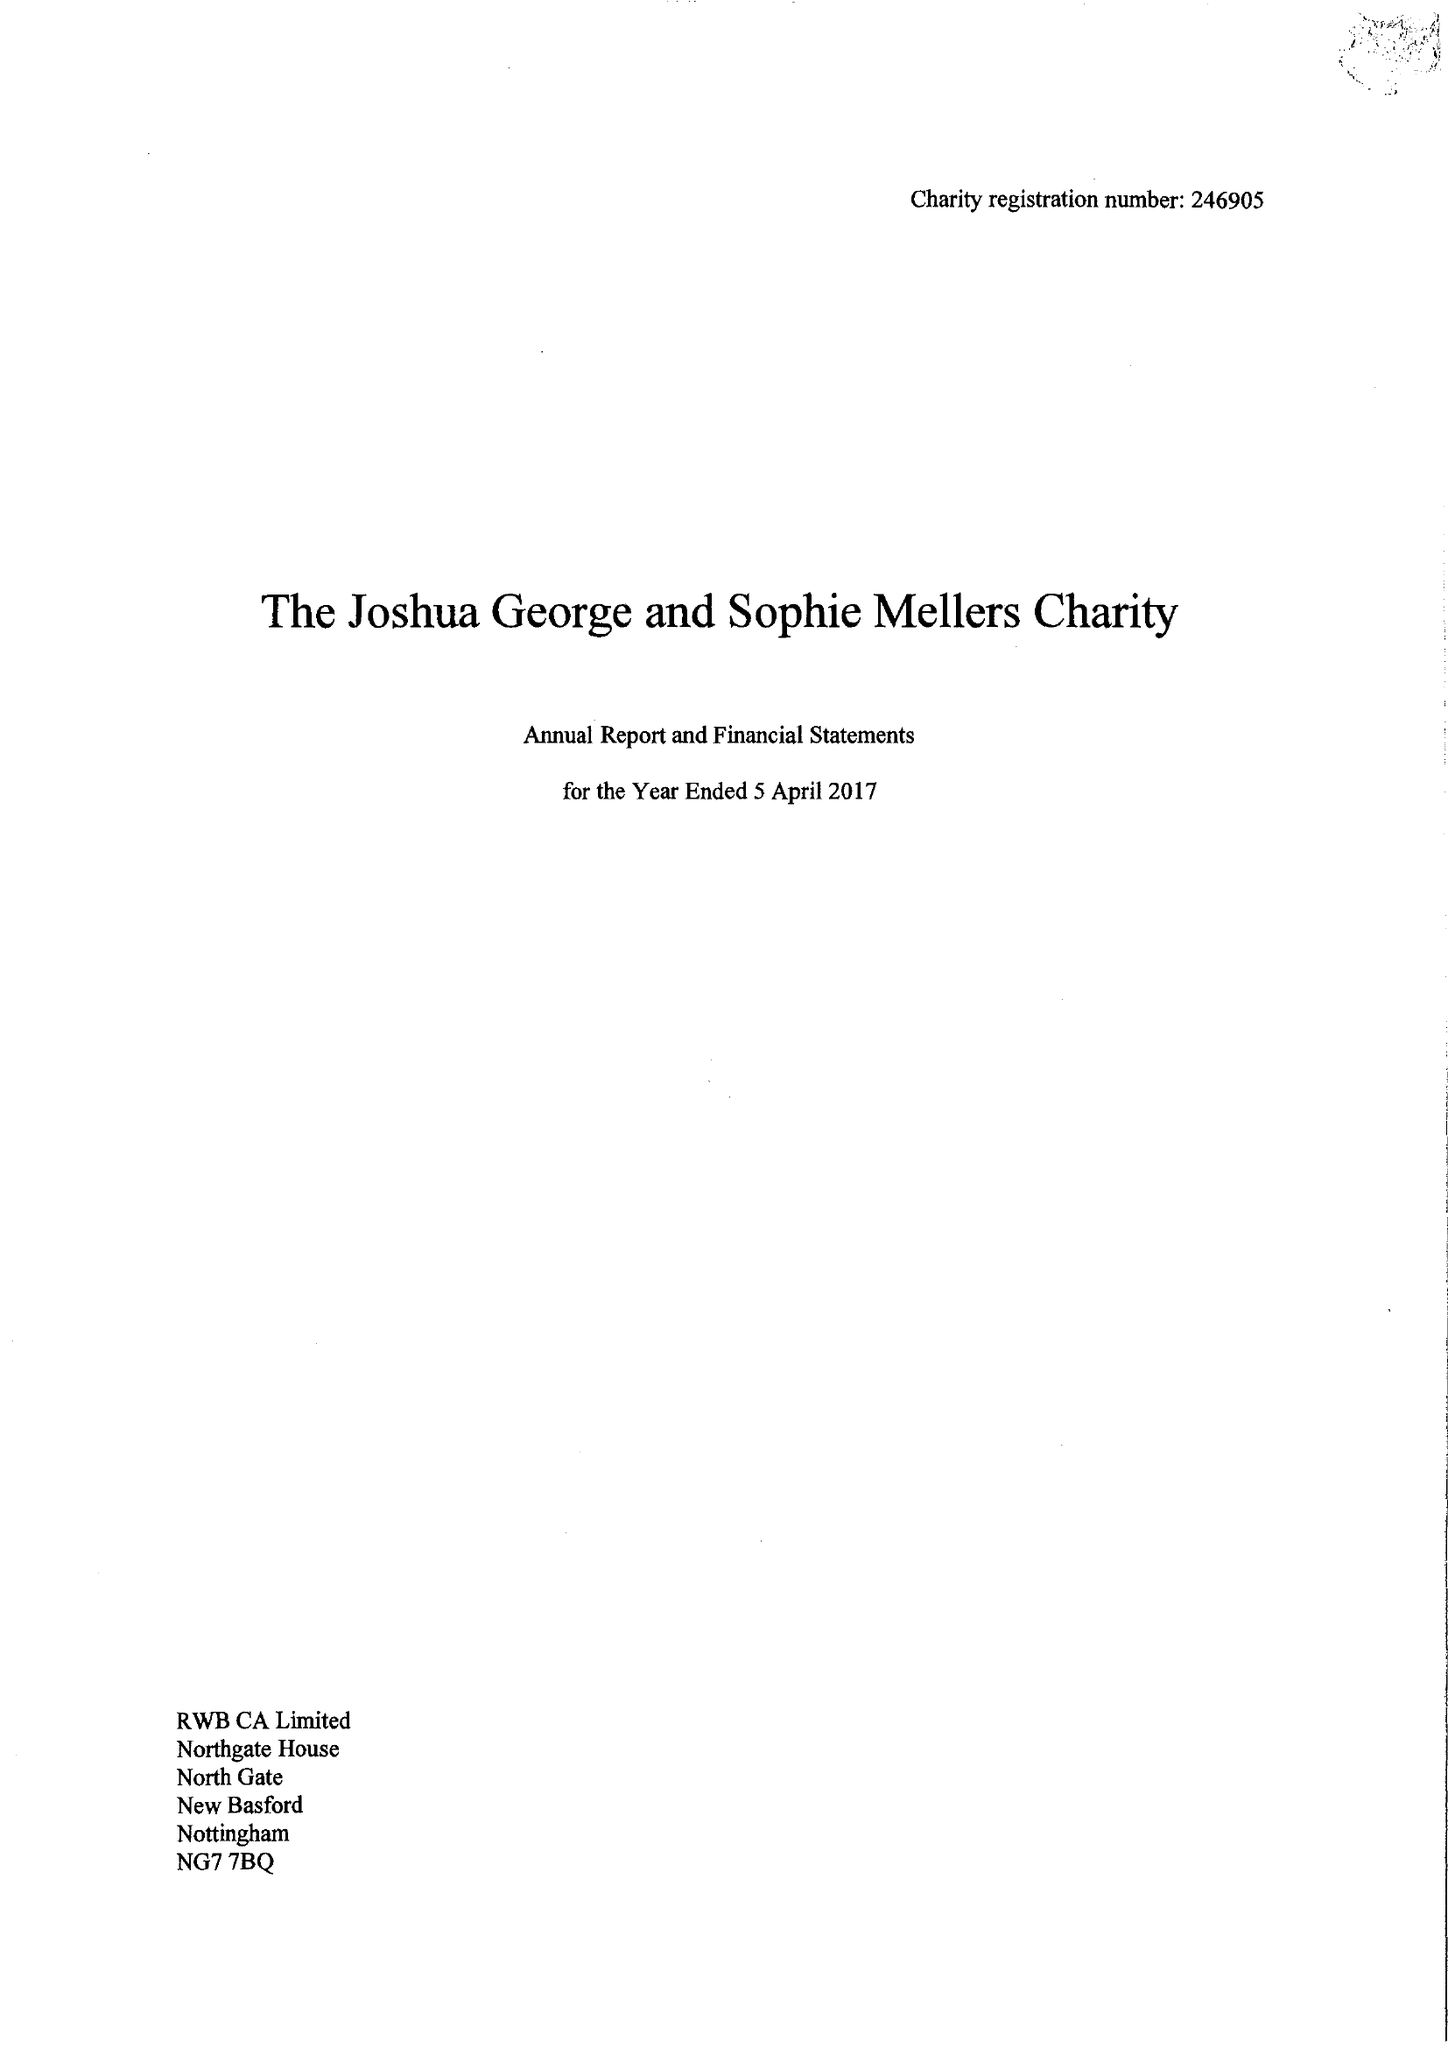What is the value for the address__postcode?
Answer the question using a single word or phrase. NG1 6HH 